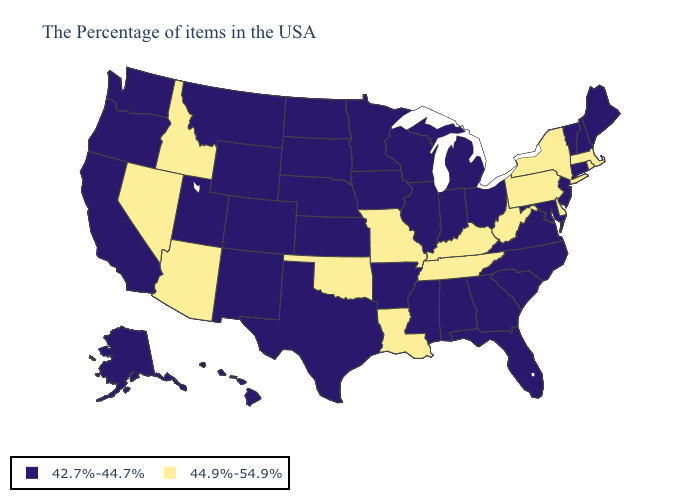What is the highest value in the South ?
Be succinct. 44.9%-54.9%. What is the highest value in the USA?
Short answer required. 44.9%-54.9%. Does Georgia have a higher value than Nebraska?
Keep it brief. No. What is the value of Oklahoma?
Give a very brief answer. 44.9%-54.9%. Which states hav the highest value in the South?
Concise answer only. Delaware, West Virginia, Kentucky, Tennessee, Louisiana, Oklahoma. What is the value of Michigan?
Short answer required. 42.7%-44.7%. Name the states that have a value in the range 44.9%-54.9%?
Give a very brief answer. Massachusetts, Rhode Island, New York, Delaware, Pennsylvania, West Virginia, Kentucky, Tennessee, Louisiana, Missouri, Oklahoma, Arizona, Idaho, Nevada. What is the value of Arkansas?
Concise answer only. 42.7%-44.7%. Name the states that have a value in the range 42.7%-44.7%?
Keep it brief. Maine, New Hampshire, Vermont, Connecticut, New Jersey, Maryland, Virginia, North Carolina, South Carolina, Ohio, Florida, Georgia, Michigan, Indiana, Alabama, Wisconsin, Illinois, Mississippi, Arkansas, Minnesota, Iowa, Kansas, Nebraska, Texas, South Dakota, North Dakota, Wyoming, Colorado, New Mexico, Utah, Montana, California, Washington, Oregon, Alaska, Hawaii. Does Iowa have the highest value in the USA?
Write a very short answer. No. Which states hav the highest value in the West?
Concise answer only. Arizona, Idaho, Nevada. Name the states that have a value in the range 44.9%-54.9%?
Be succinct. Massachusetts, Rhode Island, New York, Delaware, Pennsylvania, West Virginia, Kentucky, Tennessee, Louisiana, Missouri, Oklahoma, Arizona, Idaho, Nevada. Name the states that have a value in the range 42.7%-44.7%?
Keep it brief. Maine, New Hampshire, Vermont, Connecticut, New Jersey, Maryland, Virginia, North Carolina, South Carolina, Ohio, Florida, Georgia, Michigan, Indiana, Alabama, Wisconsin, Illinois, Mississippi, Arkansas, Minnesota, Iowa, Kansas, Nebraska, Texas, South Dakota, North Dakota, Wyoming, Colorado, New Mexico, Utah, Montana, California, Washington, Oregon, Alaska, Hawaii. What is the value of North Dakota?
Concise answer only. 42.7%-44.7%. 